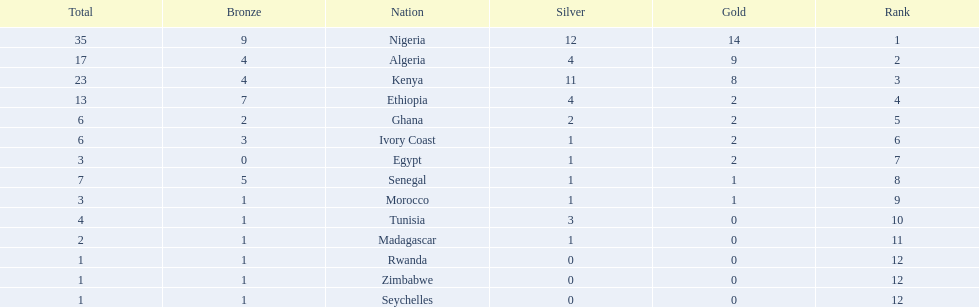What is the nation positioned immediately north of algeria? Nigeria. 